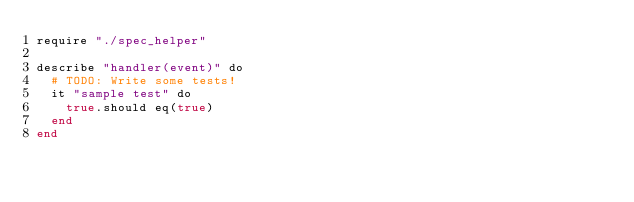Convert code to text. <code><loc_0><loc_0><loc_500><loc_500><_Crystal_>require "./spec_helper"

describe "handler(event)" do
  # TODO: Write some tests!
  it "sample test" do
    true.should eq(true)
  end
end
</code> 